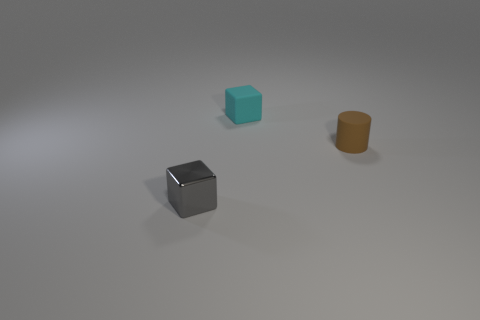There is a thing on the left side of the cube that is behind the tiny gray shiny cube; what is its size?
Offer a very short reply. Small. What number of shiny things have the same shape as the small cyan rubber thing?
Offer a very short reply. 1. How many things are objects that are behind the gray object or small gray shiny spheres?
Ensure brevity in your answer.  2. How many objects are metallic cubes or small things that are behind the small brown cylinder?
Offer a very short reply. 2. How many cyan things have the same size as the gray object?
Offer a terse response. 1. Are there fewer tiny gray things right of the cyan object than small metal things that are in front of the brown cylinder?
Give a very brief answer. Yes. How many metal things are either tiny gray cubes or blocks?
Provide a short and direct response. 1. There is a cyan rubber thing; what shape is it?
Ensure brevity in your answer.  Cube. There is a cyan thing that is the same size as the cylinder; what is its material?
Your response must be concise. Rubber. What number of small things are either shiny cubes or cyan rubber things?
Offer a terse response. 2. 